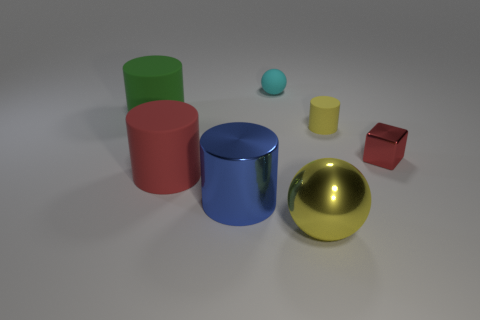Add 2 large gray metal objects. How many objects exist? 9 Subtract all cylinders. How many objects are left? 3 Add 1 big red objects. How many big red objects are left? 2 Add 7 large balls. How many large balls exist? 8 Subtract 0 cyan blocks. How many objects are left? 7 Subtract all tiny gray matte balls. Subtract all green things. How many objects are left? 6 